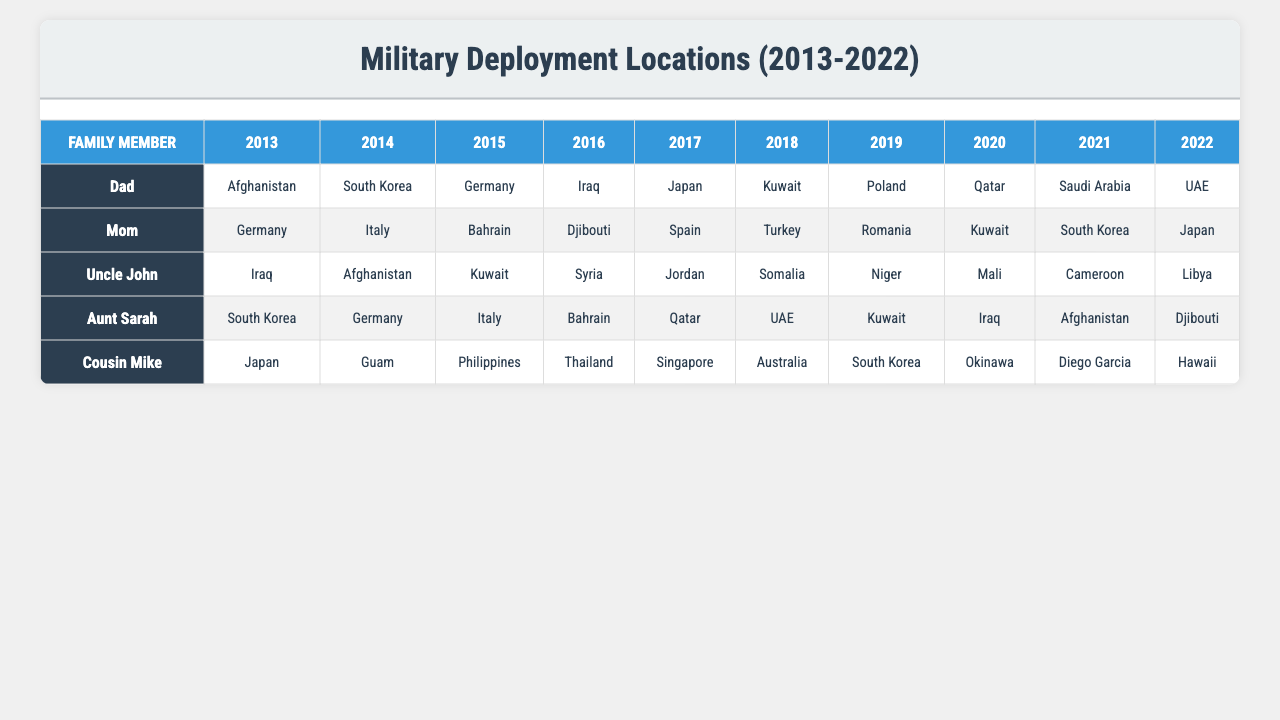What are the deployment locations for Dad in 2013? According to the table, Dad was deployed in Afghanistan in 2013.
Answer: Afghanistan How many locations did Mom deploy to? Mom was deployed to 10 different locations over the years.
Answer: 10 Is Iraq one of the deployment locations for Uncle John? Yes, Iraq is listed as one of the locations where Uncle John was deployed.
Answer: Yes Which family member had a deployment in both South Korea and Kuwait? From the data, both Dad and Aunt Sarah had deployments in South Korea and Kuwait.
Answer: Dad and Aunt Sarah What was the total number of unique deployment locations for Cousin Mike over the decade? The total number of unique locations Cousin Mike deployed to is 10.
Answer: 10 Did any family member deploy to Afghanistan more than once? Based on the data, both Dad and Aunt Sarah were deployed to Afghanistan, but we can see only one deployment each listed, so the answer is no.
Answer: No What was the most common deployment location for the family members? Analyzing the data, South Korea and Kuwait are cited multiple times across the family members, making them the most common locations.
Answer: South Korea and Kuwait How many family members were deployed to Germany? Both Dad, Mom, and Aunt Sarah had deployments to Germany, making a total of three family members.
Answer: 3 In which year did Uncle John have the most diverse number of locations? To find this, we check his listed locations. Uncle John's locations consist of 10 individual places, with no repetitions, from 2013 to 2022. Thus, the year with this diversity is not specified as it remains the same across the decade.
Answer: Not specified If we count all deployments from 2013-2022, how many total deployments have taken place? To find the total, we add the number of deployment locations each family member has: Dad (10) + Mom (10) + Uncle John (10) + Aunt Sarah (10) + Cousin Mike (10) = 50 total deployments across the decade.
Answer: 50 